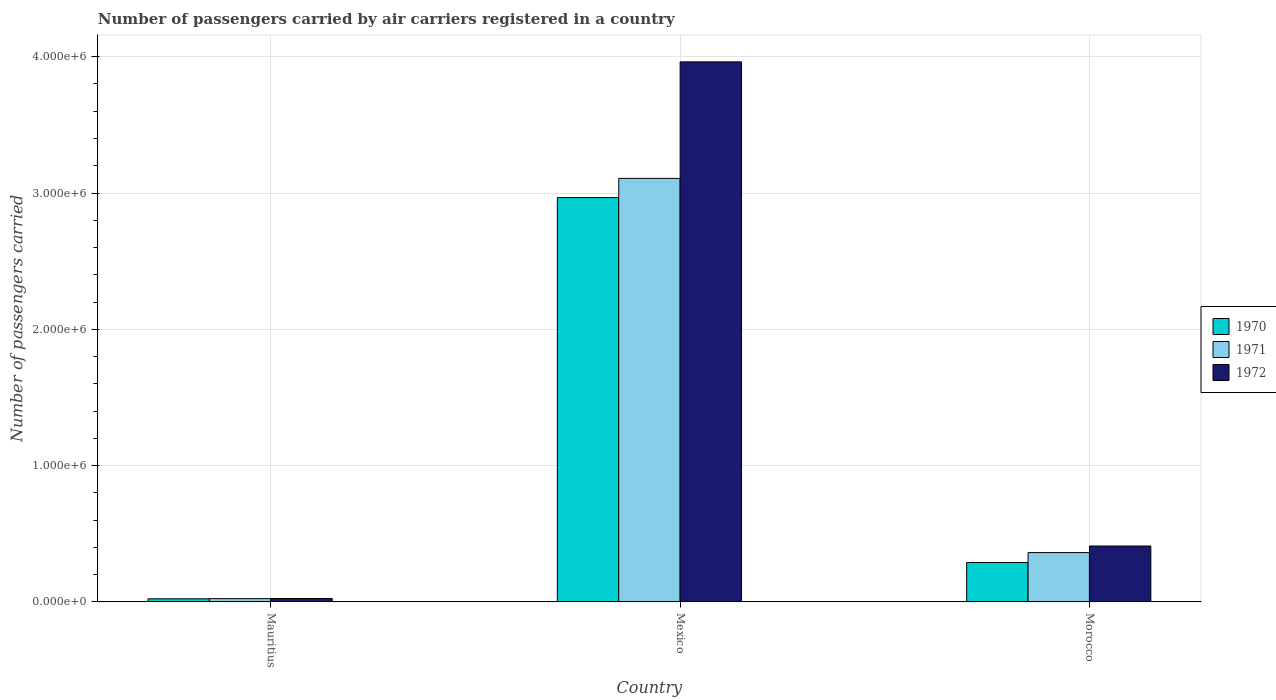Are the number of bars on each tick of the X-axis equal?
Your answer should be compact. Yes. How many bars are there on the 1st tick from the right?
Offer a terse response. 3. What is the label of the 1st group of bars from the left?
Keep it short and to the point. Mauritius. In how many cases, is the number of bars for a given country not equal to the number of legend labels?
Give a very brief answer. 0. What is the number of passengers carried by air carriers in 1971 in Morocco?
Make the answer very short. 3.62e+05. Across all countries, what is the maximum number of passengers carried by air carriers in 1972?
Keep it short and to the point. 3.96e+06. Across all countries, what is the minimum number of passengers carried by air carriers in 1970?
Make the answer very short. 2.30e+04. In which country was the number of passengers carried by air carriers in 1970 minimum?
Keep it short and to the point. Mauritius. What is the total number of passengers carried by air carriers in 1970 in the graph?
Make the answer very short. 3.28e+06. What is the difference between the number of passengers carried by air carriers in 1971 in Mauritius and that in Mexico?
Offer a very short reply. -3.08e+06. What is the difference between the number of passengers carried by air carriers in 1970 in Mexico and the number of passengers carried by air carriers in 1971 in Morocco?
Your answer should be compact. 2.60e+06. What is the average number of passengers carried by air carriers in 1972 per country?
Keep it short and to the point. 1.47e+06. What is the difference between the number of passengers carried by air carriers of/in 1972 and number of passengers carried by air carriers of/in 1971 in Mexico?
Provide a succinct answer. 8.55e+05. What is the ratio of the number of passengers carried by air carriers in 1972 in Mexico to that in Morocco?
Offer a very short reply. 9.66. What is the difference between the highest and the second highest number of passengers carried by air carriers in 1972?
Make the answer very short. 3.55e+06. What is the difference between the highest and the lowest number of passengers carried by air carriers in 1971?
Provide a short and direct response. 3.08e+06. In how many countries, is the number of passengers carried by air carriers in 1971 greater than the average number of passengers carried by air carriers in 1971 taken over all countries?
Your answer should be very brief. 1. Is the sum of the number of passengers carried by air carriers in 1971 in Mauritius and Morocco greater than the maximum number of passengers carried by air carriers in 1970 across all countries?
Your answer should be very brief. No. What does the 3rd bar from the left in Morocco represents?
Offer a very short reply. 1972. What does the 1st bar from the right in Morocco represents?
Your answer should be compact. 1972. Is it the case that in every country, the sum of the number of passengers carried by air carriers in 1972 and number of passengers carried by air carriers in 1970 is greater than the number of passengers carried by air carriers in 1971?
Offer a terse response. Yes. Are all the bars in the graph horizontal?
Your answer should be very brief. No. How many countries are there in the graph?
Offer a very short reply. 3. What is the difference between two consecutive major ticks on the Y-axis?
Provide a succinct answer. 1.00e+06. Are the values on the major ticks of Y-axis written in scientific E-notation?
Keep it short and to the point. Yes. Does the graph contain any zero values?
Your response must be concise. No. Does the graph contain grids?
Offer a very short reply. Yes. Where does the legend appear in the graph?
Offer a terse response. Center right. How many legend labels are there?
Your answer should be compact. 3. How are the legend labels stacked?
Give a very brief answer. Vertical. What is the title of the graph?
Make the answer very short. Number of passengers carried by air carriers registered in a country. Does "2005" appear as one of the legend labels in the graph?
Ensure brevity in your answer.  No. What is the label or title of the Y-axis?
Offer a very short reply. Number of passengers carried. What is the Number of passengers carried in 1970 in Mauritius?
Your answer should be very brief. 2.30e+04. What is the Number of passengers carried of 1971 in Mauritius?
Give a very brief answer. 2.42e+04. What is the Number of passengers carried in 1972 in Mauritius?
Give a very brief answer. 2.52e+04. What is the Number of passengers carried in 1970 in Mexico?
Offer a very short reply. 2.97e+06. What is the Number of passengers carried of 1971 in Mexico?
Your answer should be very brief. 3.11e+06. What is the Number of passengers carried in 1972 in Mexico?
Give a very brief answer. 3.96e+06. What is the Number of passengers carried of 1970 in Morocco?
Make the answer very short. 2.90e+05. What is the Number of passengers carried in 1971 in Morocco?
Your answer should be very brief. 3.62e+05. What is the Number of passengers carried of 1972 in Morocco?
Provide a succinct answer. 4.10e+05. Across all countries, what is the maximum Number of passengers carried of 1970?
Give a very brief answer. 2.97e+06. Across all countries, what is the maximum Number of passengers carried of 1971?
Your answer should be very brief. 3.11e+06. Across all countries, what is the maximum Number of passengers carried of 1972?
Your answer should be very brief. 3.96e+06. Across all countries, what is the minimum Number of passengers carried of 1970?
Provide a short and direct response. 2.30e+04. Across all countries, what is the minimum Number of passengers carried of 1971?
Your response must be concise. 2.42e+04. Across all countries, what is the minimum Number of passengers carried of 1972?
Provide a short and direct response. 2.52e+04. What is the total Number of passengers carried in 1970 in the graph?
Your answer should be very brief. 3.28e+06. What is the total Number of passengers carried in 1971 in the graph?
Provide a short and direct response. 3.49e+06. What is the total Number of passengers carried in 1972 in the graph?
Provide a succinct answer. 4.40e+06. What is the difference between the Number of passengers carried in 1970 in Mauritius and that in Mexico?
Your response must be concise. -2.94e+06. What is the difference between the Number of passengers carried in 1971 in Mauritius and that in Mexico?
Make the answer very short. -3.08e+06. What is the difference between the Number of passengers carried of 1972 in Mauritius and that in Mexico?
Give a very brief answer. -3.94e+06. What is the difference between the Number of passengers carried of 1970 in Mauritius and that in Morocco?
Provide a succinct answer. -2.66e+05. What is the difference between the Number of passengers carried of 1971 in Mauritius and that in Morocco?
Ensure brevity in your answer.  -3.38e+05. What is the difference between the Number of passengers carried in 1972 in Mauritius and that in Morocco?
Your answer should be very brief. -3.85e+05. What is the difference between the Number of passengers carried in 1970 in Mexico and that in Morocco?
Your answer should be compact. 2.68e+06. What is the difference between the Number of passengers carried in 1971 in Mexico and that in Morocco?
Your answer should be compact. 2.75e+06. What is the difference between the Number of passengers carried of 1972 in Mexico and that in Morocco?
Offer a very short reply. 3.55e+06. What is the difference between the Number of passengers carried of 1970 in Mauritius and the Number of passengers carried of 1971 in Mexico?
Offer a very short reply. -3.08e+06. What is the difference between the Number of passengers carried of 1970 in Mauritius and the Number of passengers carried of 1972 in Mexico?
Give a very brief answer. -3.94e+06. What is the difference between the Number of passengers carried in 1971 in Mauritius and the Number of passengers carried in 1972 in Mexico?
Provide a short and direct response. -3.94e+06. What is the difference between the Number of passengers carried of 1970 in Mauritius and the Number of passengers carried of 1971 in Morocco?
Your answer should be compact. -3.39e+05. What is the difference between the Number of passengers carried of 1970 in Mauritius and the Number of passengers carried of 1972 in Morocco?
Offer a very short reply. -3.87e+05. What is the difference between the Number of passengers carried of 1971 in Mauritius and the Number of passengers carried of 1972 in Morocco?
Your answer should be very brief. -3.86e+05. What is the difference between the Number of passengers carried in 1970 in Mexico and the Number of passengers carried in 1971 in Morocco?
Ensure brevity in your answer.  2.60e+06. What is the difference between the Number of passengers carried of 1970 in Mexico and the Number of passengers carried of 1972 in Morocco?
Keep it short and to the point. 2.56e+06. What is the difference between the Number of passengers carried of 1971 in Mexico and the Number of passengers carried of 1972 in Morocco?
Your response must be concise. 2.70e+06. What is the average Number of passengers carried in 1970 per country?
Provide a short and direct response. 1.09e+06. What is the average Number of passengers carried of 1971 per country?
Your answer should be compact. 1.16e+06. What is the average Number of passengers carried of 1972 per country?
Keep it short and to the point. 1.47e+06. What is the difference between the Number of passengers carried of 1970 and Number of passengers carried of 1971 in Mauritius?
Offer a very short reply. -1200. What is the difference between the Number of passengers carried of 1970 and Number of passengers carried of 1972 in Mauritius?
Your response must be concise. -2200. What is the difference between the Number of passengers carried in 1971 and Number of passengers carried in 1972 in Mauritius?
Your response must be concise. -1000. What is the difference between the Number of passengers carried in 1970 and Number of passengers carried in 1971 in Mexico?
Provide a short and direct response. -1.41e+05. What is the difference between the Number of passengers carried in 1970 and Number of passengers carried in 1972 in Mexico?
Provide a short and direct response. -9.95e+05. What is the difference between the Number of passengers carried in 1971 and Number of passengers carried in 1972 in Mexico?
Keep it short and to the point. -8.55e+05. What is the difference between the Number of passengers carried of 1970 and Number of passengers carried of 1971 in Morocco?
Keep it short and to the point. -7.25e+04. What is the difference between the Number of passengers carried of 1970 and Number of passengers carried of 1972 in Morocco?
Make the answer very short. -1.21e+05. What is the difference between the Number of passengers carried in 1971 and Number of passengers carried in 1972 in Morocco?
Your answer should be compact. -4.83e+04. What is the ratio of the Number of passengers carried of 1970 in Mauritius to that in Mexico?
Your answer should be compact. 0.01. What is the ratio of the Number of passengers carried in 1971 in Mauritius to that in Mexico?
Ensure brevity in your answer.  0.01. What is the ratio of the Number of passengers carried in 1972 in Mauritius to that in Mexico?
Provide a short and direct response. 0.01. What is the ratio of the Number of passengers carried in 1970 in Mauritius to that in Morocco?
Your response must be concise. 0.08. What is the ratio of the Number of passengers carried in 1971 in Mauritius to that in Morocco?
Your response must be concise. 0.07. What is the ratio of the Number of passengers carried in 1972 in Mauritius to that in Morocco?
Give a very brief answer. 0.06. What is the ratio of the Number of passengers carried in 1970 in Mexico to that in Morocco?
Offer a terse response. 10.25. What is the ratio of the Number of passengers carried in 1971 in Mexico to that in Morocco?
Your answer should be very brief. 8.58. What is the ratio of the Number of passengers carried in 1972 in Mexico to that in Morocco?
Offer a terse response. 9.66. What is the difference between the highest and the second highest Number of passengers carried in 1970?
Provide a short and direct response. 2.68e+06. What is the difference between the highest and the second highest Number of passengers carried in 1971?
Make the answer very short. 2.75e+06. What is the difference between the highest and the second highest Number of passengers carried of 1972?
Your response must be concise. 3.55e+06. What is the difference between the highest and the lowest Number of passengers carried of 1970?
Make the answer very short. 2.94e+06. What is the difference between the highest and the lowest Number of passengers carried in 1971?
Provide a succinct answer. 3.08e+06. What is the difference between the highest and the lowest Number of passengers carried of 1972?
Offer a terse response. 3.94e+06. 